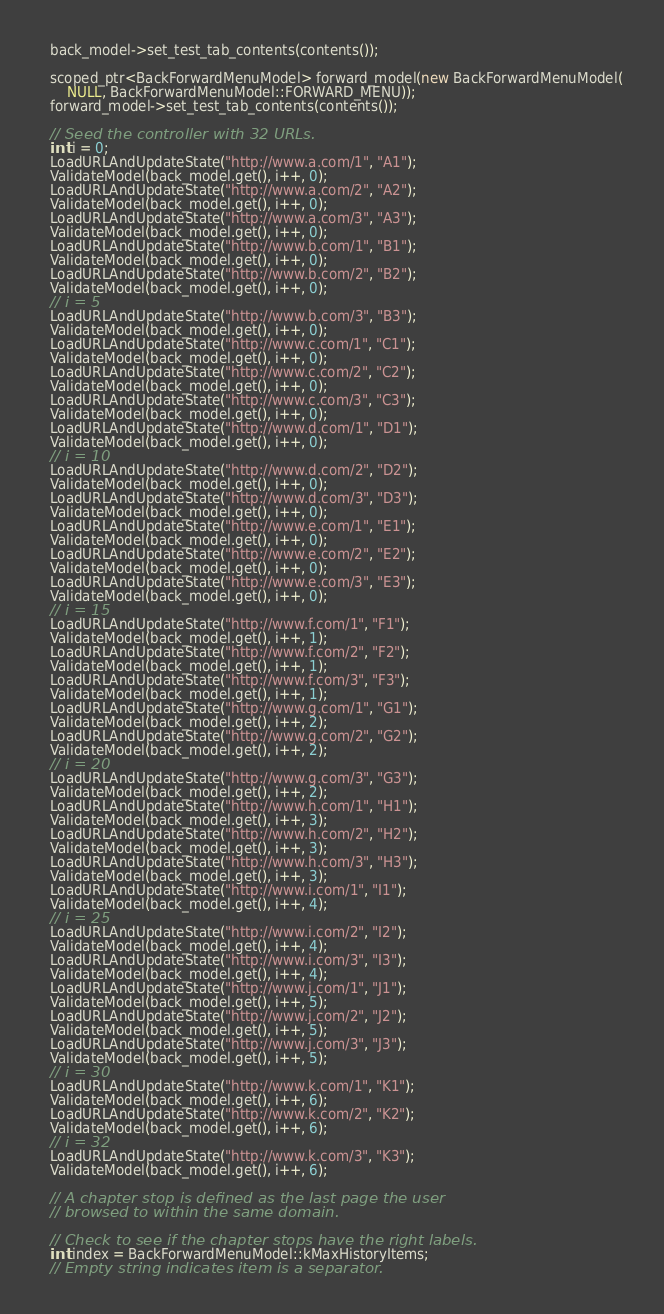<code> <loc_0><loc_0><loc_500><loc_500><_C++_>  back_model->set_test_tab_contents(contents());

  scoped_ptr<BackForwardMenuModel> forward_model(new BackForwardMenuModel(
      NULL, BackForwardMenuModel::FORWARD_MENU));
  forward_model->set_test_tab_contents(contents());

  // Seed the controller with 32 URLs.
  int i = 0;
  LoadURLAndUpdateState("http://www.a.com/1", "A1");
  ValidateModel(back_model.get(), i++, 0);
  LoadURLAndUpdateState("http://www.a.com/2", "A2");
  ValidateModel(back_model.get(), i++, 0);
  LoadURLAndUpdateState("http://www.a.com/3", "A3");
  ValidateModel(back_model.get(), i++, 0);
  LoadURLAndUpdateState("http://www.b.com/1", "B1");
  ValidateModel(back_model.get(), i++, 0);
  LoadURLAndUpdateState("http://www.b.com/2", "B2");
  ValidateModel(back_model.get(), i++, 0);
  // i = 5
  LoadURLAndUpdateState("http://www.b.com/3", "B3");
  ValidateModel(back_model.get(), i++, 0);
  LoadURLAndUpdateState("http://www.c.com/1", "C1");
  ValidateModel(back_model.get(), i++, 0);
  LoadURLAndUpdateState("http://www.c.com/2", "C2");
  ValidateModel(back_model.get(), i++, 0);
  LoadURLAndUpdateState("http://www.c.com/3", "C3");
  ValidateModel(back_model.get(), i++, 0);
  LoadURLAndUpdateState("http://www.d.com/1", "D1");
  ValidateModel(back_model.get(), i++, 0);
  // i = 10
  LoadURLAndUpdateState("http://www.d.com/2", "D2");
  ValidateModel(back_model.get(), i++, 0);
  LoadURLAndUpdateState("http://www.d.com/3", "D3");
  ValidateModel(back_model.get(), i++, 0);
  LoadURLAndUpdateState("http://www.e.com/1", "E1");
  ValidateModel(back_model.get(), i++, 0);
  LoadURLAndUpdateState("http://www.e.com/2", "E2");
  ValidateModel(back_model.get(), i++, 0);
  LoadURLAndUpdateState("http://www.e.com/3", "E3");
  ValidateModel(back_model.get(), i++, 0);
  // i = 15
  LoadURLAndUpdateState("http://www.f.com/1", "F1");
  ValidateModel(back_model.get(), i++, 1);
  LoadURLAndUpdateState("http://www.f.com/2", "F2");
  ValidateModel(back_model.get(), i++, 1);
  LoadURLAndUpdateState("http://www.f.com/3", "F3");
  ValidateModel(back_model.get(), i++, 1);
  LoadURLAndUpdateState("http://www.g.com/1", "G1");
  ValidateModel(back_model.get(), i++, 2);
  LoadURLAndUpdateState("http://www.g.com/2", "G2");
  ValidateModel(back_model.get(), i++, 2);
  // i = 20
  LoadURLAndUpdateState("http://www.g.com/3", "G3");
  ValidateModel(back_model.get(), i++, 2);
  LoadURLAndUpdateState("http://www.h.com/1", "H1");
  ValidateModel(back_model.get(), i++, 3);
  LoadURLAndUpdateState("http://www.h.com/2", "H2");
  ValidateModel(back_model.get(), i++, 3);
  LoadURLAndUpdateState("http://www.h.com/3", "H3");
  ValidateModel(back_model.get(), i++, 3);
  LoadURLAndUpdateState("http://www.i.com/1", "I1");
  ValidateModel(back_model.get(), i++, 4);
  // i = 25
  LoadURLAndUpdateState("http://www.i.com/2", "I2");
  ValidateModel(back_model.get(), i++, 4);
  LoadURLAndUpdateState("http://www.i.com/3", "I3");
  ValidateModel(back_model.get(), i++, 4);
  LoadURLAndUpdateState("http://www.j.com/1", "J1");
  ValidateModel(back_model.get(), i++, 5);
  LoadURLAndUpdateState("http://www.j.com/2", "J2");
  ValidateModel(back_model.get(), i++, 5);
  LoadURLAndUpdateState("http://www.j.com/3", "J3");
  ValidateModel(back_model.get(), i++, 5);
  // i = 30
  LoadURLAndUpdateState("http://www.k.com/1", "K1");
  ValidateModel(back_model.get(), i++, 6);
  LoadURLAndUpdateState("http://www.k.com/2", "K2");
  ValidateModel(back_model.get(), i++, 6);
  // i = 32
  LoadURLAndUpdateState("http://www.k.com/3", "K3");
  ValidateModel(back_model.get(), i++, 6);

  // A chapter stop is defined as the last page the user
  // browsed to within the same domain.

  // Check to see if the chapter stops have the right labels.
  int index = BackForwardMenuModel::kMaxHistoryItems;
  // Empty string indicates item is a separator.</code> 